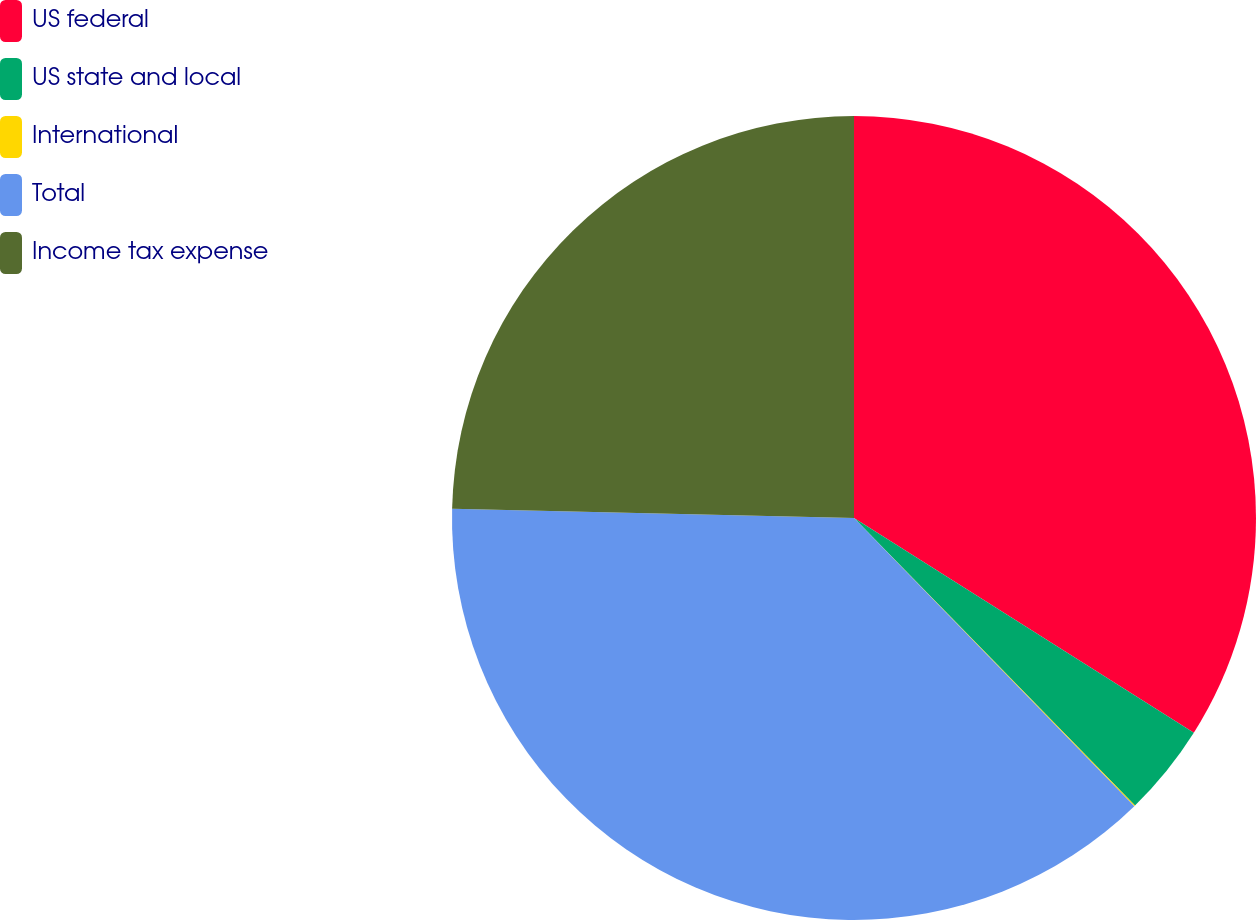Convert chart to OTSL. <chart><loc_0><loc_0><loc_500><loc_500><pie_chart><fcel>US federal<fcel>US state and local<fcel>International<fcel>Total<fcel>Income tax expense<nl><fcel>33.97%<fcel>3.71%<fcel>0.04%<fcel>37.65%<fcel>24.63%<nl></chart> 